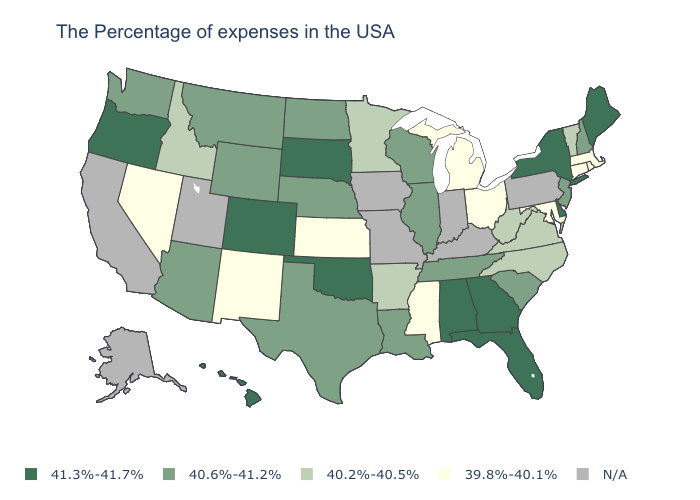What is the value of Nebraska?
Short answer required. 40.6%-41.2%. Name the states that have a value in the range 40.2%-40.5%?
Concise answer only. Vermont, Virginia, North Carolina, West Virginia, Arkansas, Minnesota, Idaho. Does the map have missing data?
Write a very short answer. Yes. What is the value of Alabama?
Quick response, please. 41.3%-41.7%. What is the highest value in states that border Michigan?
Answer briefly. 40.6%-41.2%. Among the states that border Nebraska , which have the lowest value?
Answer briefly. Kansas. What is the value of Utah?
Quick response, please. N/A. Does New York have the highest value in the USA?
Write a very short answer. Yes. Does South Carolina have the lowest value in the South?
Write a very short answer. No. Which states hav the highest value in the West?
Concise answer only. Colorado, Oregon, Hawaii. What is the value of Wyoming?
Quick response, please. 40.6%-41.2%. What is the value of Tennessee?
Quick response, please. 40.6%-41.2%. Is the legend a continuous bar?
Answer briefly. No. 